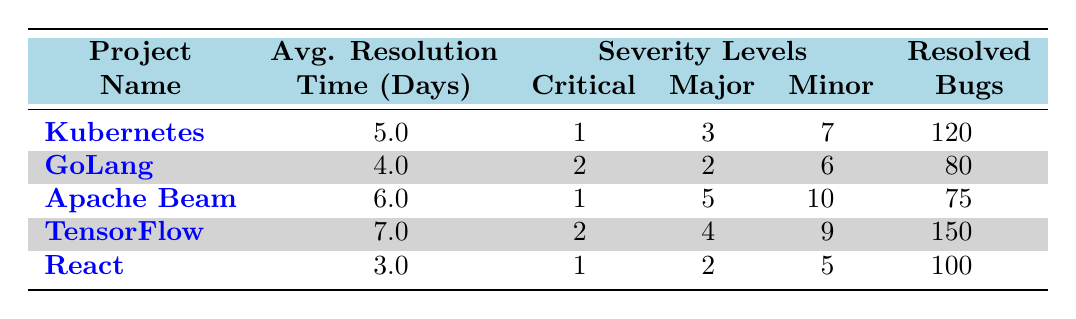What is the average resolution time for the Kubernetes project? The table shows that the average resolution time for the Kubernetes project is listed under the "Avg. Resolution Time" column. The value next to it is 5.0 days.
Answer: 5.0 days Which project has the highest number of resolved bugs? By examining the "Resolved Bugs" column, we can see the counts for each project: Kubernetes (120), GoLang (80), Apache Beam (75), TensorFlow (150), and React (100). The highest value is 150 for TensorFlow.
Answer: TensorFlow How many critical severity level bugs were resolved in the React project? The table indicates that under the "Severity Levels" column for the React project, there is a value of 1 for Critical severity level bugs.
Answer: 1 Which project has the shortest average resolution time, and what is that time? By reviewing the "Avg. Resolution Time" column, we can find the lowest value among Kubernetes (5.0), GoLang (4.0), Apache Beam (6.0), TensorFlow (7.0), and React (3.0). The lowest value is 3.0 days for the React project.
Answer: React, 3.0 days Is the average resolution time for Apache Beam greater than the average resolution time for GoLang? The average resolution time for Apache Beam is 6.0 days, and for GoLang, it is 4.0 days. Since 6.0 is greater than 4.0, the statement is true.
Answer: Yes How many total critical severity bugs were resolved across all projects? We need to add up the critical severity bugs for each project: Kubernetes (1), GoLang (2), Apache Beam (1), TensorFlow (2), and React (1). The total is 1 + 2 + 1 + 2 + 1 = 7.
Answer: 7 What is the difference in average resolution time between the project with the highest and the lowest average resolution time? The project with the highest average resolution time is TensorFlow (7.0 days) and the lowest is React (3.0 days). The difference is calculated as 7.0 - 3.0 = 4.0 days.
Answer: 4.0 days Which project has five or more major severity level bugs resolved? By looking at the "Major" column, we see that Kubernetes (3), GoLang (2), Apache Beam (5), TensorFlow (4), and React (2) are listed. The only project that meets the criterion of five or more major bugs resolved is Apache Beam.
Answer: Apache Beam Are there more minor bugs resolved in TensorFlow than in Kubernetes? The minor bug counts are 9 for TensorFlow and 7 for Kubernetes. Since 9 is greater than 7, the statement is true.
Answer: Yes 